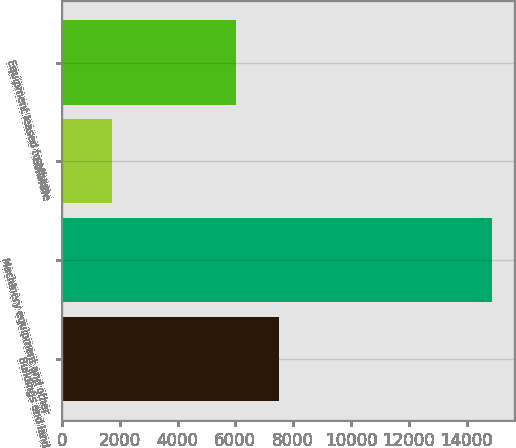<chart> <loc_0><loc_0><loc_500><loc_500><bar_chart><fcel>Buildings and land<fcel>Machinery equipment and other<fcel>Software<fcel>Equipment leased to others<nl><fcel>7515<fcel>14888<fcel>1745<fcel>6038<nl></chart> 